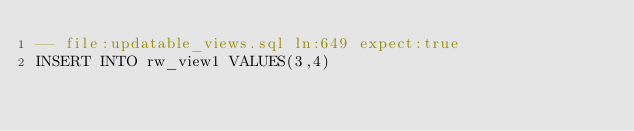Convert code to text. <code><loc_0><loc_0><loc_500><loc_500><_SQL_>-- file:updatable_views.sql ln:649 expect:true
INSERT INTO rw_view1 VALUES(3,4)
</code> 